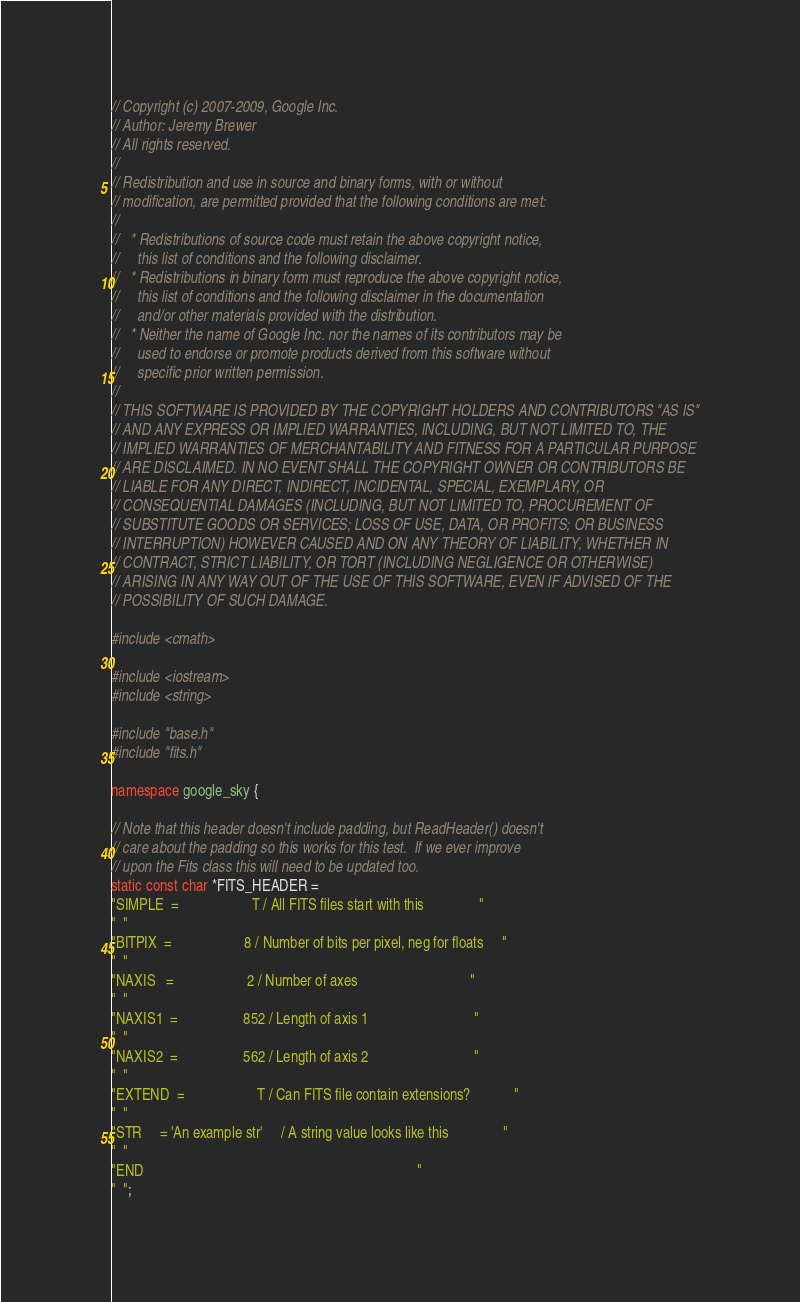<code> <loc_0><loc_0><loc_500><loc_500><_C++_>// Copyright (c) 2007-2009, Google Inc.
// Author: Jeremy Brewer
// All rights reserved.
// 
// Redistribution and use in source and binary forms, with or without
// modification, are permitted provided that the following conditions are met:
// 
//   * Redistributions of source code must retain the above copyright notice,
//     this list of conditions and the following disclaimer.
//   * Redistributions in binary form must reproduce the above copyright notice,
//     this list of conditions and the following disclaimer in the documentation
//     and/or other materials provided with the distribution.
//   * Neither the name of Google Inc. nor the names of its contributors may be
//     used to endorse or promote products derived from this software without
//     specific prior written permission.
// 
// THIS SOFTWARE IS PROVIDED BY THE COPYRIGHT HOLDERS AND CONTRIBUTORS "AS IS"
// AND ANY EXPRESS OR IMPLIED WARRANTIES, INCLUDING, BUT NOT LIMITED TO, THE
// IMPLIED WARRANTIES OF MERCHANTABILITY AND FITNESS FOR A PARTICULAR PURPOSE
// ARE DISCLAIMED. IN NO EVENT SHALL THE COPYRIGHT OWNER OR CONTRIBUTORS BE
// LIABLE FOR ANY DIRECT, INDIRECT, INCIDENTAL, SPECIAL, EXEMPLARY, OR
// CONSEQUENTIAL DAMAGES (INCLUDING, BUT NOT LIMITED TO, PROCUREMENT OF
// SUBSTITUTE GOODS OR SERVICES; LOSS OF USE, DATA, OR PROFITS; OR BUSINESS
// INTERRUPTION) HOWEVER CAUSED AND ON ANY THEORY OF LIABILITY, WHETHER IN
// CONTRACT, STRICT LIABILITY, OR TORT (INCLUDING NEGLIGENCE OR OTHERWISE)
// ARISING IN ANY WAY OUT OF THE USE OF THIS SOFTWARE, EVEN IF ADVISED OF THE
// POSSIBILITY OF SUCH DAMAGE.

#include <cmath>

#include <iostream>
#include <string>

#include "base.h"
#include "fits.h"

namespace google_sky {

// Note that this header doesn't include padding, but ReadHeader() doesn't
// care about the padding so this works for this test.  If we ever improve
// upon the Fits class this will need to be updated too.
static const char *FITS_HEADER =
"SIMPLE  =                    T / All FITS files start with this               "
"  "
"BITPIX  =                    8 / Number of bits per pixel, neg for floats     "
"  "
"NAXIS   =                    2 / Number of axes                               "
"  "
"NAXIS1  =                  852 / Length of axis 1                             "
"  "
"NAXIS2  =                  562 / Length of axis 2                             "
"  "
"EXTEND  =                    T / Can FITS file contain extensions?            "
"  "
"STR     = 'An example str'     / A string value looks like this               "
"  "
"END                                                                           "
"  ";
</code> 